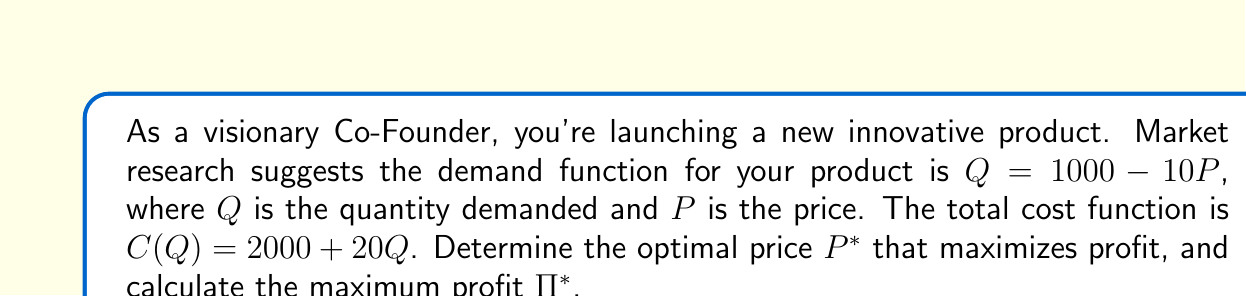Can you answer this question? To solve this problem, we'll follow these steps:

1) First, let's define the profit function $\Pi(P)$:
   $\Pi(P) = \text{Revenue} - \text{Cost}$

2) Revenue is price times quantity: $P \cdot Q$
   Cost is given by $C(Q)$

3) Substituting the demand function $Q = 1000 - 10P$ into the revenue and cost functions:
   $\Pi(P) = P(1000 - 10P) - [2000 + 20(1000 - 10P)]$

4) Expanding this:
   $\Pi(P) = 1000P - 10P^2 - 2000 - 20000 + 200P$
   $\Pi(P) = 1200P - 10P^2 - 22000$

5) To find the maximum profit, we differentiate $\Pi(P)$ with respect to $P$ and set it to zero:
   $$\frac{d\Pi}{dP} = 1200 - 20P = 0$$

6) Solving this equation:
   $1200 - 20P = 0$
   $20P = 1200$
   $P^* = 60$

7) To confirm this is a maximum, we can check the second derivative:
   $$\frac{d^2\Pi}{dP^2} = -20 < 0$$
   This confirms $P^* = 60$ gives a maximum.

8) To find the maximum profit, we substitute $P^* = 60$ back into the profit function:
   $\Pi^* = 1200(60) - 10(60)^2 - 22000$
   $\Pi^* = 72000 - 36000 - 22000 = 14000$

Therefore, the optimal price is $60, and the maximum profit is $14,000.
Answer: Optimal price $P^* = $60
Maximum profit $\Pi^* = $14,000 